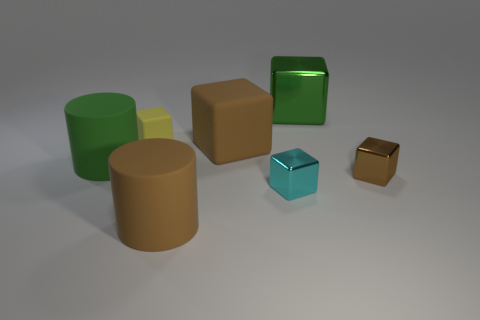How many other things are there of the same shape as the large green shiny thing?
Your response must be concise. 4. How big is the green shiny object?
Your response must be concise. Large. How big is the object that is both behind the large brown matte cube and left of the brown cylinder?
Give a very brief answer. Small. There is a big green object on the left side of the green cube; what is its shape?
Provide a succinct answer. Cylinder. Are the tiny yellow block and the large object to the right of the cyan metallic thing made of the same material?
Offer a terse response. No. Is the shape of the green metallic thing the same as the yellow object?
Provide a short and direct response. Yes. There is a small cyan object that is the same shape as the large green shiny thing; what is its material?
Ensure brevity in your answer.  Metal. What is the color of the rubber object that is behind the big brown rubber cylinder and to the right of the yellow object?
Your response must be concise. Brown. The big metallic cube is what color?
Offer a very short reply. Green. There is a tiny block that is the same color as the large matte block; what is its material?
Offer a very short reply. Metal. 